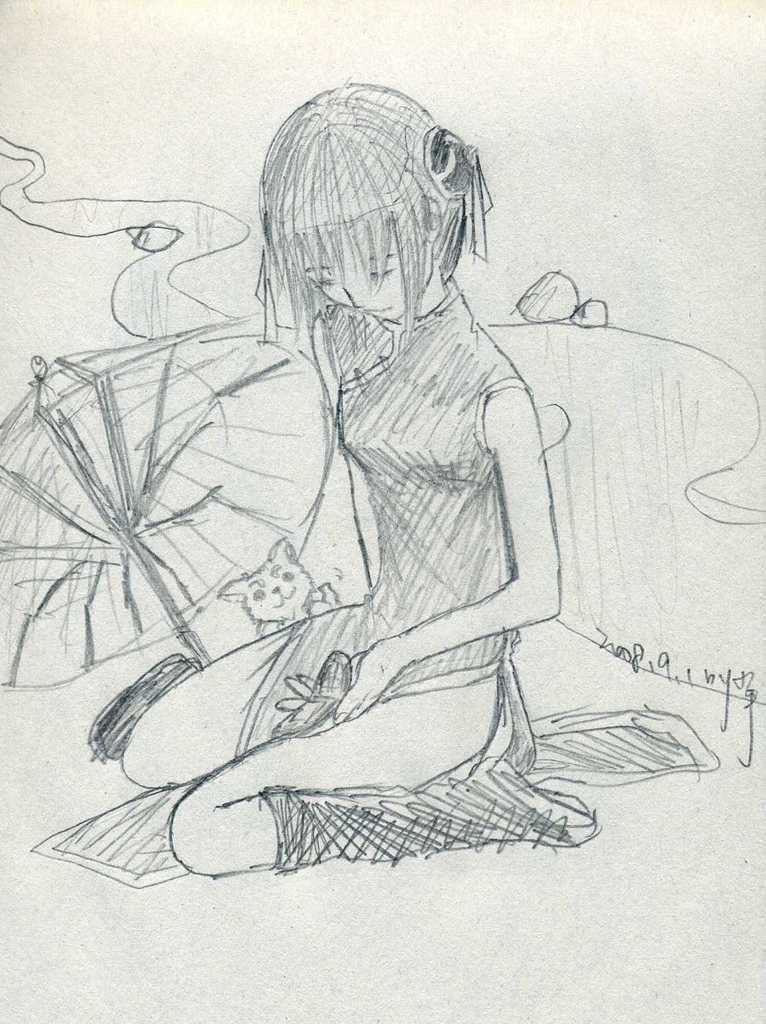What is the main subject of the image? There is an art piece in the image. What is the name of the iron veil depicted in the art piece? There is no iron veil present in the image, as the only fact provided is that there is an art piece in the image. 